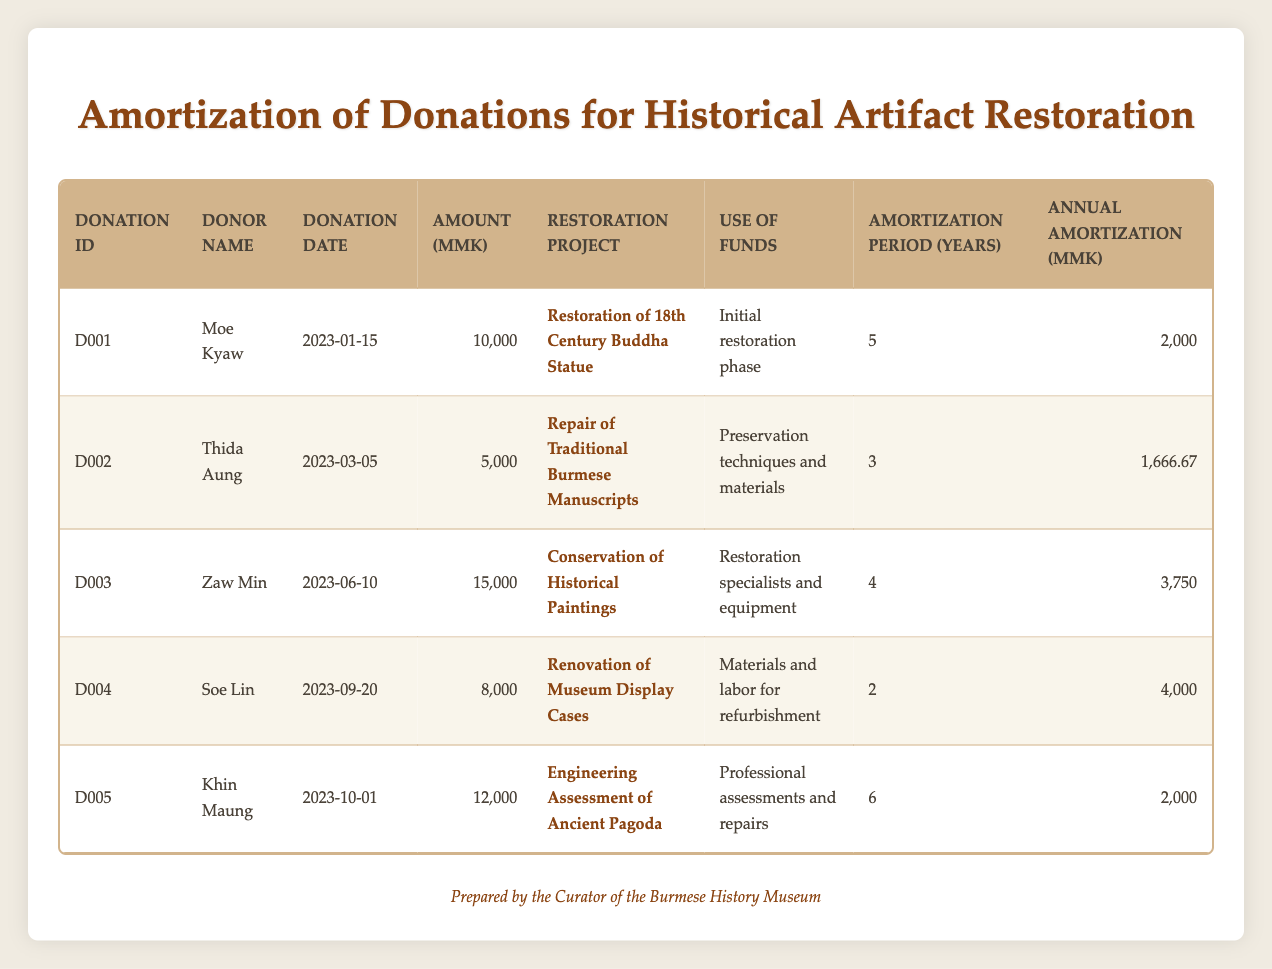What is the total amount of donations made for the restoration projects? To find the total amount of donations, we sum the "Amount" values from all entries: 10,000 + 5,000 + 15,000 + 8,000 + 12,000 = 50,000
Answer: 50,000 Which donation has the longest amortization period? Reviewing the "Amortization Period (Years)" column, the longest period is 6 years for the donation made by Khin Maung.
Answer: Khin Maung (D005) What is the average annual amortization across all donation entries? To find the average, first sum the annual amortization amounts: 2,000 + 1,666.67 + 3,750 + 4,000 + 2,000 = 13,416.67. Then divide by the number of donations (5): 13,416.67 / 5 = 2,683.33
Answer: 2,683.33 Did Moe Kyaw contribute more than any other donor? Comparing Moe Kyaw's donation amount of 10,000 with others: Thida Aung (5,000), Zaw Min (15,000), Soe Lin (8,000), and Khin Maung (12,000), only Zaw Min contributed more. Thus, the statement is false.
Answer: No What percentage of the total donations does the largest single donation represent? The largest donation is 15,000 from Zaw Min. The total donations are 50,000. To find the percentage: (15,000 / 50,000) * 100 = 30%.
Answer: 30% How many donors contributed to the restoration of display cases? Soe Lin is the only donor listed for the renovation of museum display cases in the table.
Answer: 1 What is the total annual amortization for all donations dedicated to manuscripts and paintings? The relevant annual amortization amounts are: for D002 (1,666.67) and D003 (3,750). Adding these together: 1,666.67 + 3,750 = 5,416.67.
Answer: 5,416.67 Was the donation for the renovation of display cases made before or after the donation for the engineering assessment? Soe Lin's donation for the renovation of display cases was made on 2023-09-20, and Khin Maung's donation for the engineering assessment was made on 2023-10-01. Thus, the display cases donation was made before.
Answer: Before 